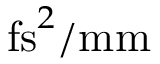Convert formula to latex. <formula><loc_0><loc_0><loc_500><loc_500>f s ^ { 2 } / m m</formula> 